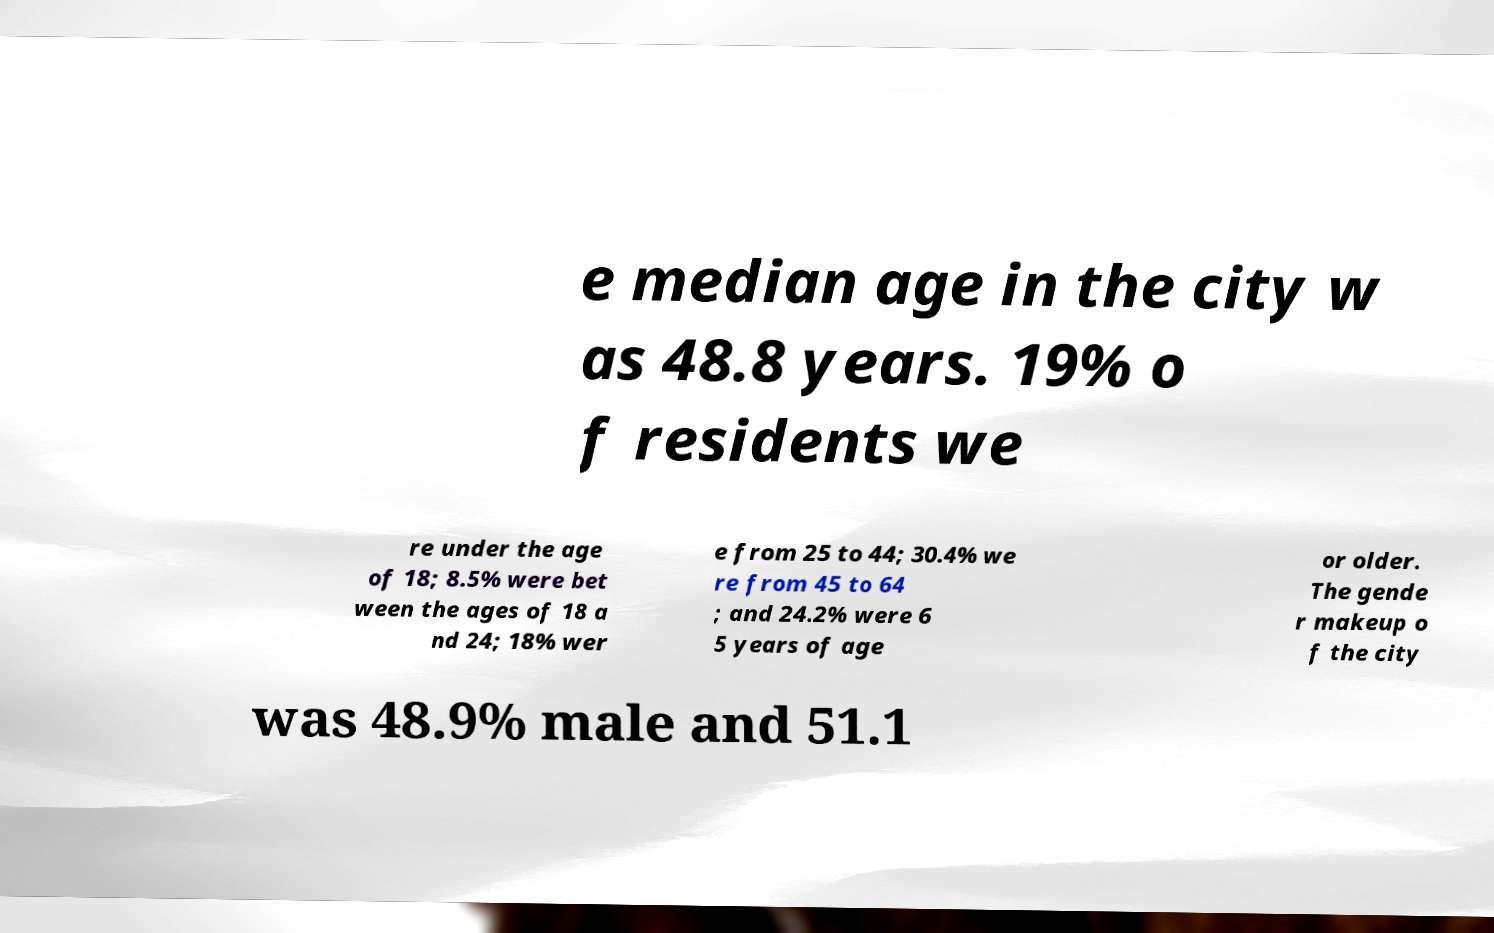What messages or text are displayed in this image? I need them in a readable, typed format. e median age in the city w as 48.8 years. 19% o f residents we re under the age of 18; 8.5% were bet ween the ages of 18 a nd 24; 18% wer e from 25 to 44; 30.4% we re from 45 to 64 ; and 24.2% were 6 5 years of age or older. The gende r makeup o f the city was 48.9% male and 51.1 